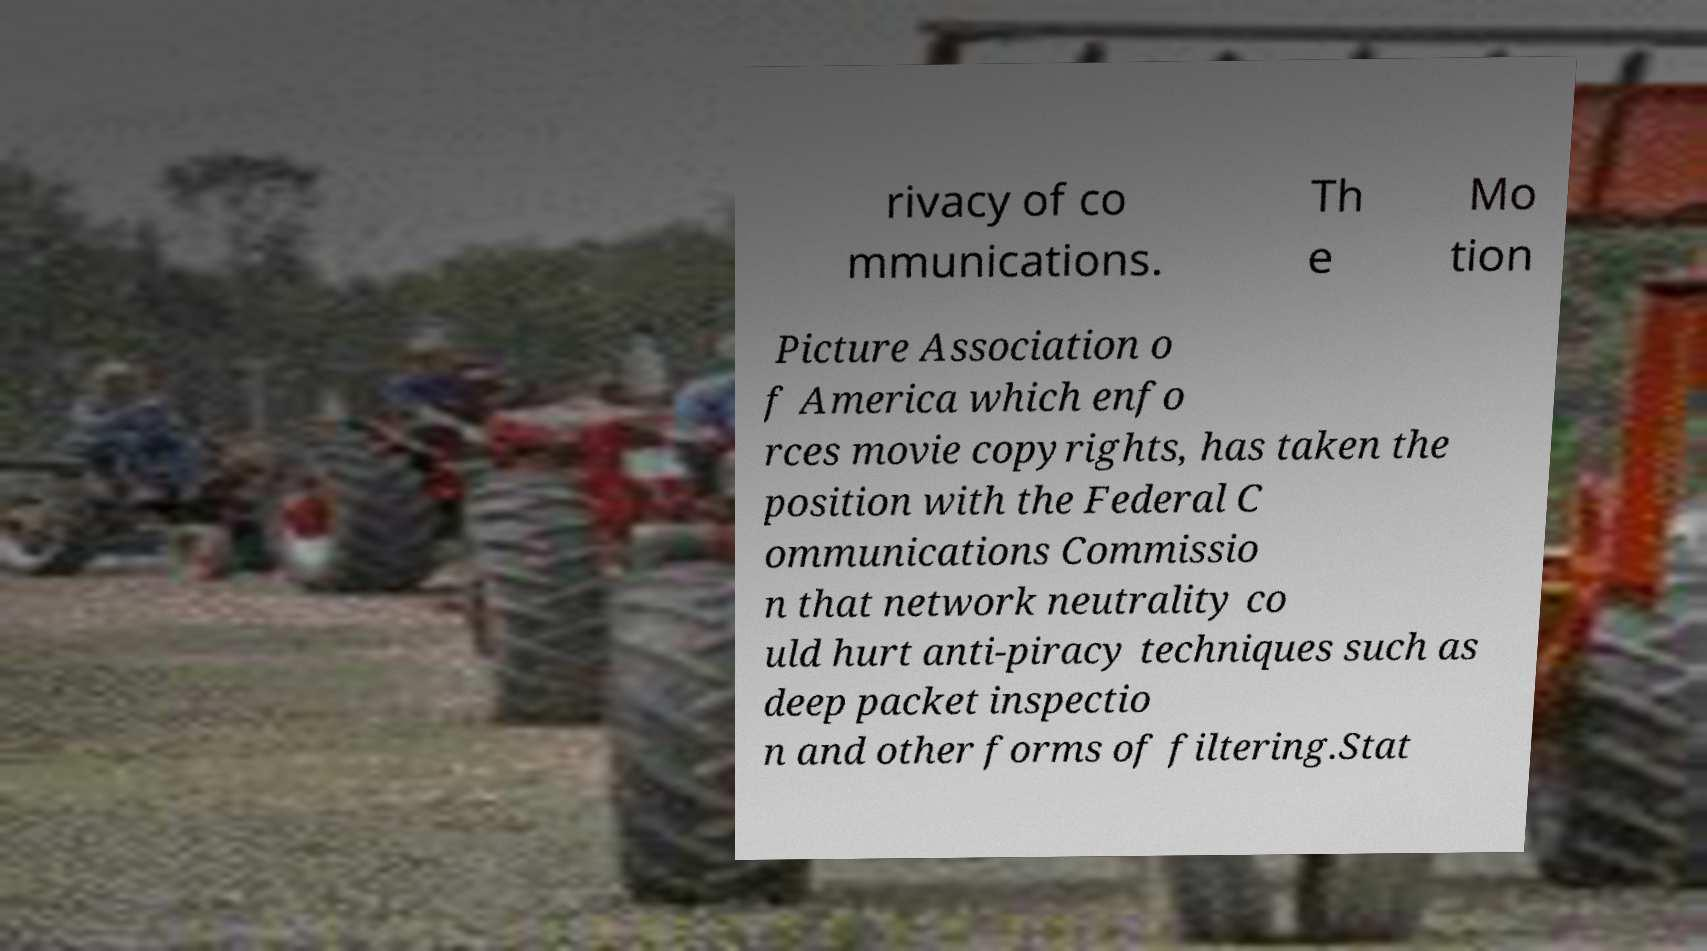Could you extract and type out the text from this image? rivacy of co mmunications. Th e Mo tion Picture Association o f America which enfo rces movie copyrights, has taken the position with the Federal C ommunications Commissio n that network neutrality co uld hurt anti-piracy techniques such as deep packet inspectio n and other forms of filtering.Stat 